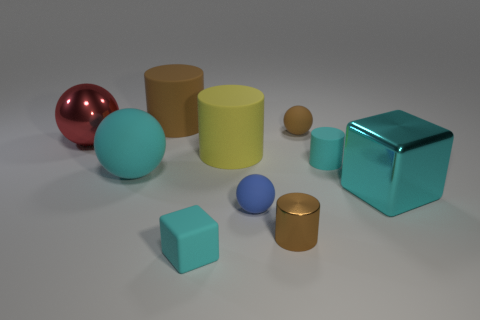What material is the yellow cylinder that is the same size as the cyan metallic thing?
Offer a terse response. Rubber. Is there a tiny brown sphere made of the same material as the tiny blue ball?
Provide a short and direct response. Yes. There is a tiny cylinder that is behind the large metallic thing that is in front of the large matte object that is in front of the large yellow cylinder; what color is it?
Provide a short and direct response. Cyan. There is a block that is left of the cyan metallic cube; is it the same color as the cylinder left of the cyan matte cube?
Provide a short and direct response. No. Is there any other thing of the same color as the metal cylinder?
Provide a short and direct response. Yes. Is the number of small metallic objects that are behind the small brown metal cylinder less than the number of tiny brown metallic cylinders?
Make the answer very short. Yes. What number of big red matte balls are there?
Give a very brief answer. 0. Does the large cyan rubber object have the same shape as the big rubber thing that is behind the tiny brown sphere?
Make the answer very short. No. Are there fewer tiny cyan matte things that are on the right side of the big cyan rubber sphere than cylinders that are right of the large brown matte cylinder?
Your answer should be compact. Yes. Are there any other things that are the same shape as the small blue matte thing?
Offer a terse response. Yes. 